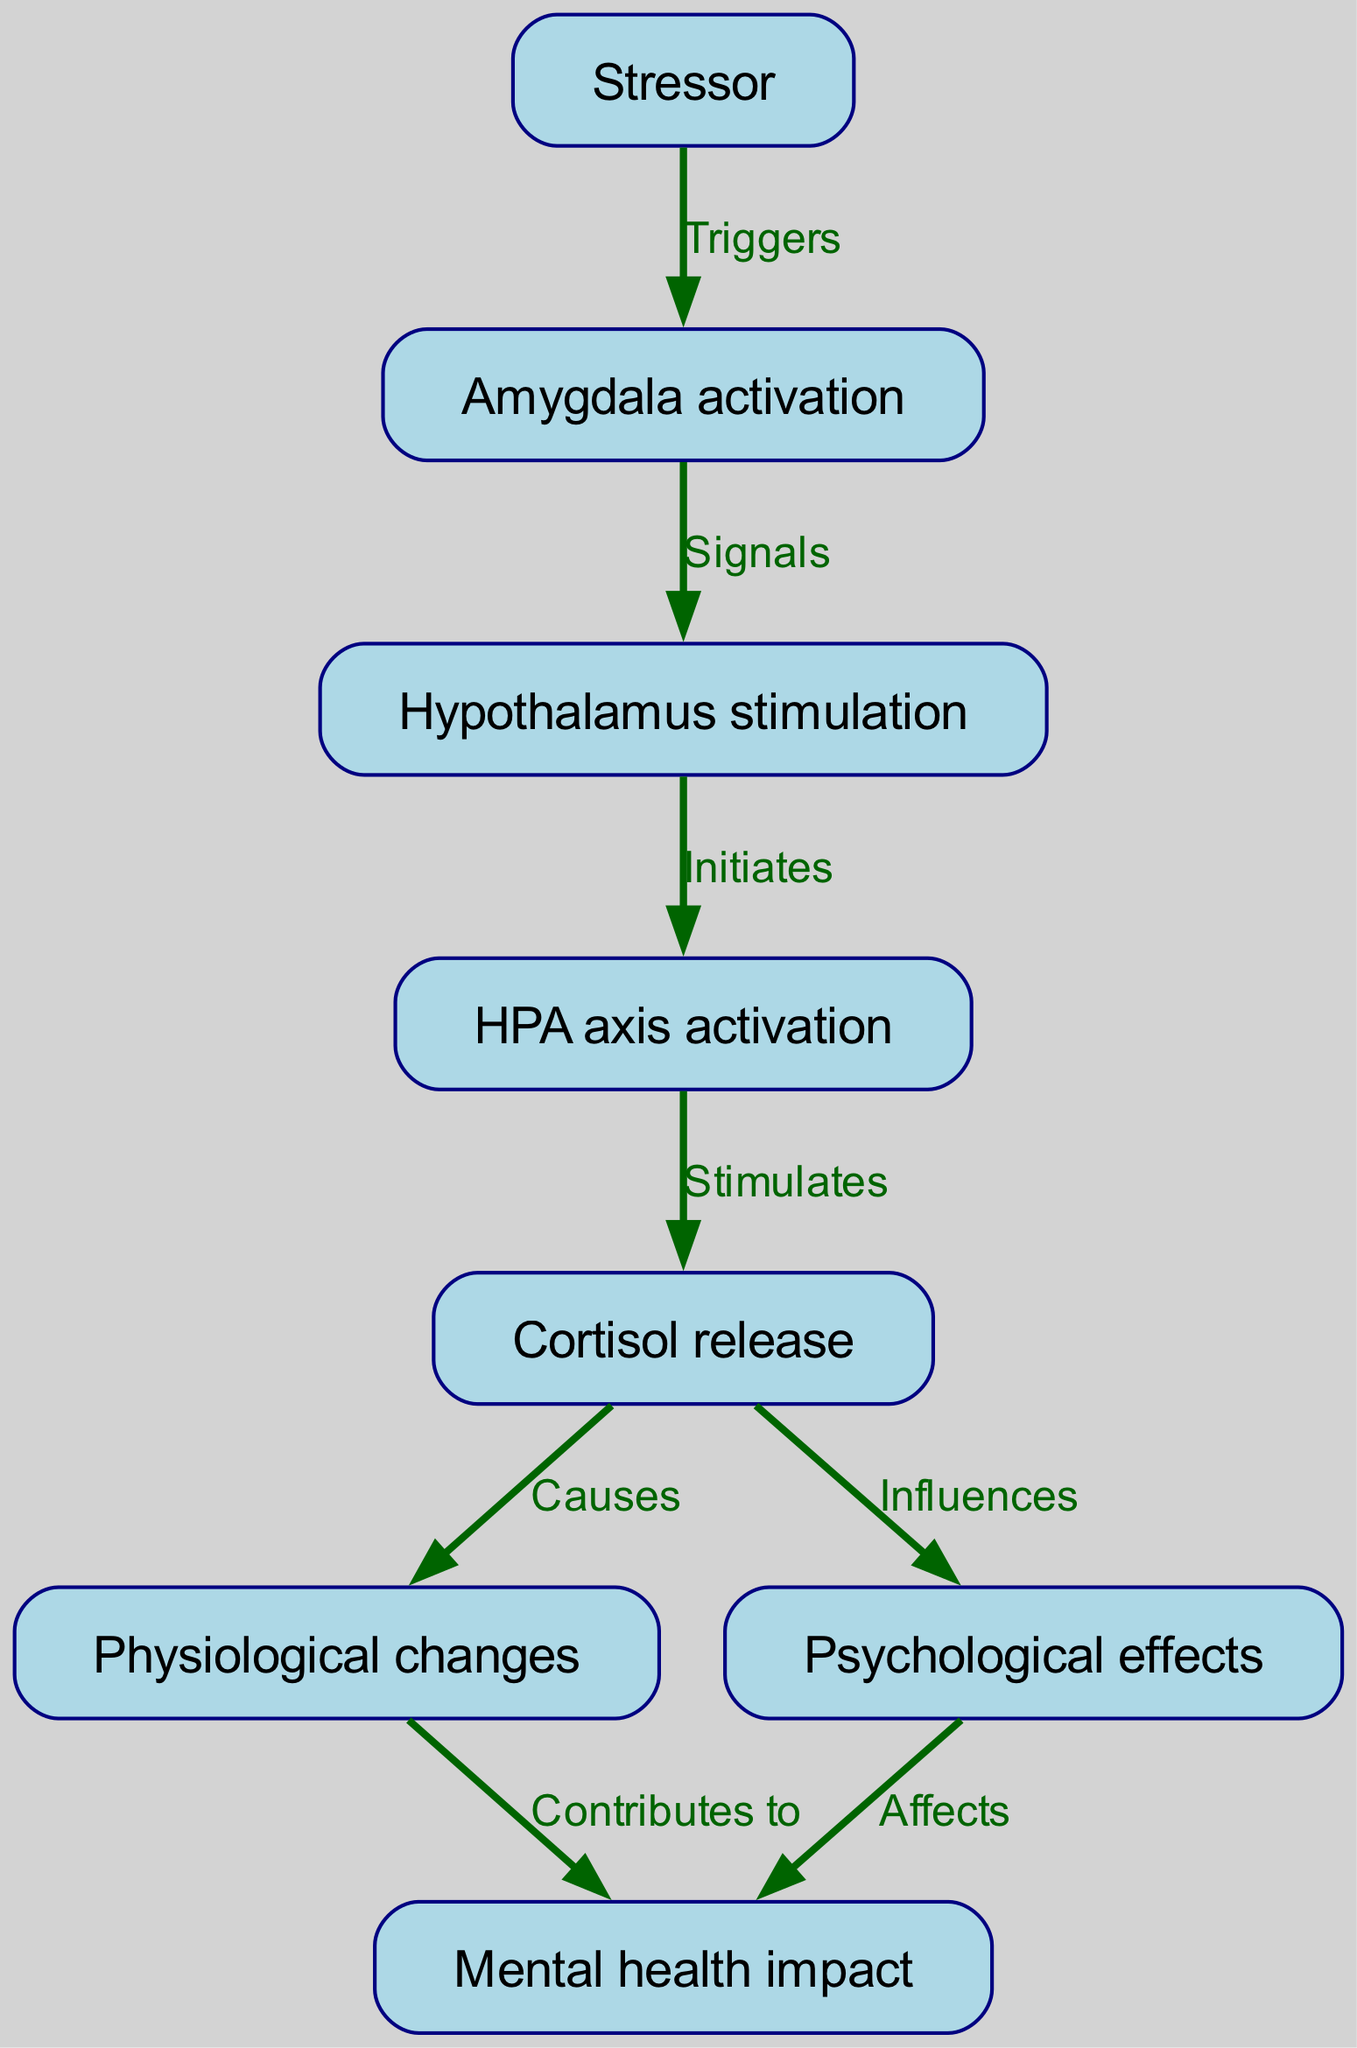What is the first node in the flow chart? The first node in the flow chart is 'Stressor', which is indicated as the starting point before any processes are triggered.
Answer: Stressor How many nodes are present in the diagram? Counting each of the distinct elements in the flow chart, there are a total of eight nodes listed, which represent different stages in the stress response process.
Answer: 8 What is the relationship between 'Cortisol release' and 'Physiological changes'? The diagram indicates that 'Cortisol release' causes 'Physiological changes', establishing a direct link between the two nodes where the release of cortisol affects the body physiologically.
Answer: Causes What does the 'Amygdala activation' signal to next in the flow chart? Based on the flow described, 'Amygdala activation' signals the 'Hypothalamus stimulation', marking a critical step in the stress response cascade.
Answer: Hypothalamus stimulation Which node is impacted by both 'Cortisol release' and 'Psychological effects'? The 'Mental health impact' node is influenced by both 'Cortisol release' and 'Psychological effects', showing how these two processes contribute to mental health outcomes.
Answer: Mental health impact What initiates the activation of the HPA axis? The activation of the HPA axis is initiated by the stimulation of the 'Hypothalamus', demonstrating a sequential process where one event triggers the next in the stress response.
Answer: Hypothalamus stimulation How does 'Physiological changes' relate to 'Mental health impact'? The flow chart indicates that 'Physiological changes' contributes to the 'Mental health impact', implying that changes in the body due to stress can lead to mental health consequences.
Answer: Contributes to What are the two effects of 'Cortisol release'? 'Cortisol release' influences both 'Physiological changes' and 'Psychological effects', indicating that cortisol has both physical and mental effects during stress response.
Answer: Physiological changes and Psychological effects 